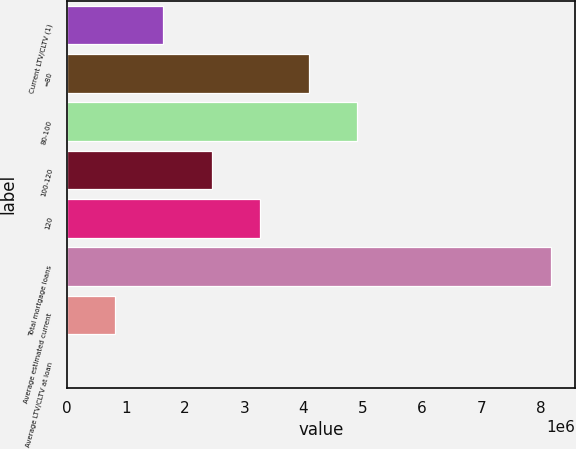Convert chart. <chart><loc_0><loc_0><loc_500><loc_500><bar_chart><fcel>Current LTV/CLTV (1)<fcel>=80<fcel>80-100<fcel>100-120<fcel>120<fcel>Total mortgage loans<fcel>Average estimated current<fcel>Average LTV/CLTV at loan<nl><fcel>1.63412e+06<fcel>4.0852e+06<fcel>4.90223e+06<fcel>2.45115e+06<fcel>3.26817e+06<fcel>8.17033e+06<fcel>817096<fcel>70.6<nl></chart> 